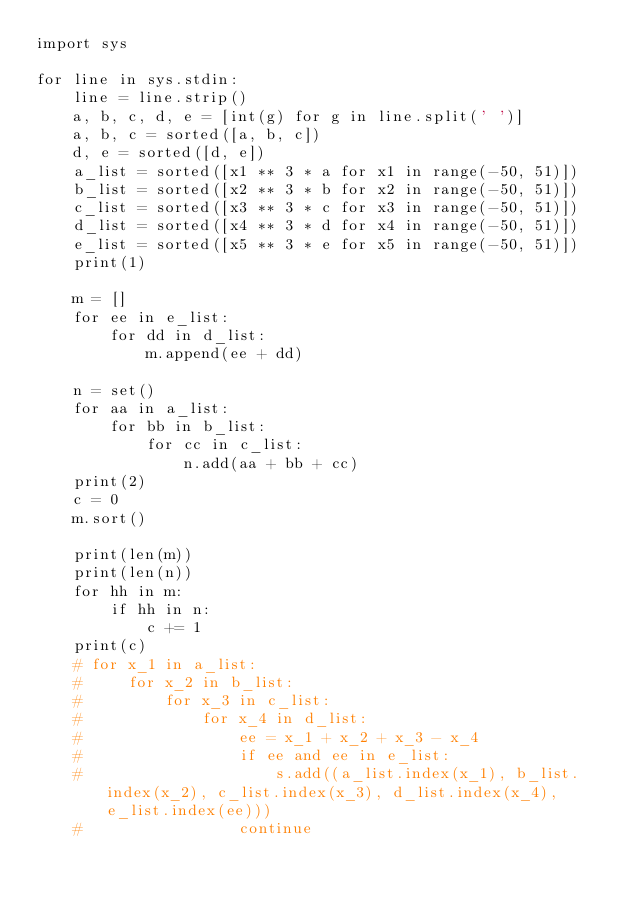Convert code to text. <code><loc_0><loc_0><loc_500><loc_500><_Python_>import sys

for line in sys.stdin:
    line = line.strip()
    a, b, c, d, e = [int(g) for g in line.split(' ')]
    a, b, c = sorted([a, b, c])
    d, e = sorted([d, e])
    a_list = sorted([x1 ** 3 * a for x1 in range(-50, 51)])
    b_list = sorted([x2 ** 3 * b for x2 in range(-50, 51)])
    c_list = sorted([x3 ** 3 * c for x3 in range(-50, 51)])
    d_list = sorted([x4 ** 3 * d for x4 in range(-50, 51)])
    e_list = sorted([x5 ** 3 * e for x5 in range(-50, 51)])
    print(1)

    m = []
    for ee in e_list:
        for dd in d_list:
            m.append(ee + dd)

    n = set()
    for aa in a_list:
        for bb in b_list:
            for cc in c_list:
                n.add(aa + bb + cc)
    print(2)
    c = 0
    m.sort()

    print(len(m))
    print(len(n))
    for hh in m:
        if hh in n:
            c += 1
    print(c)
    # for x_1 in a_list:
    #     for x_2 in b_list:
    #         for x_3 in c_list:
    #             for x_4 in d_list:
    #                 ee = x_1 + x_2 + x_3 - x_4
    #                 if ee and ee in e_list:
    #                     s.add((a_list.index(x_1), b_list.index(x_2), c_list.index(x_3), d_list.index(x_4), e_list.index(ee)))
    #                 continue
</code> 